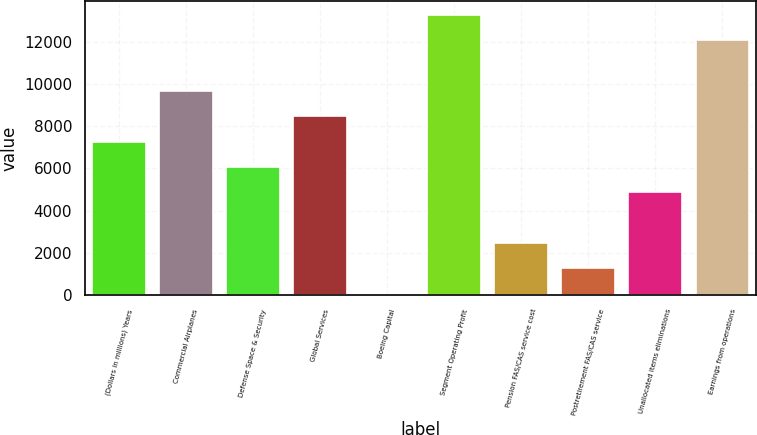Convert chart. <chart><loc_0><loc_0><loc_500><loc_500><bar_chart><fcel>(Dollars in millions) Years<fcel>Commercial Airplanes<fcel>Defense Space & Security<fcel>Global Services<fcel>Boeing Capital<fcel>Segment Operating Profit<fcel>Pension FAS/CAS service cost<fcel>Postretirement FAS/CAS service<fcel>Unallocated items eliminations<fcel>Earnings from operations<nl><fcel>7276<fcel>9675<fcel>6076.5<fcel>8475.5<fcel>79<fcel>13273.5<fcel>2478<fcel>1278.5<fcel>4877<fcel>12074<nl></chart> 